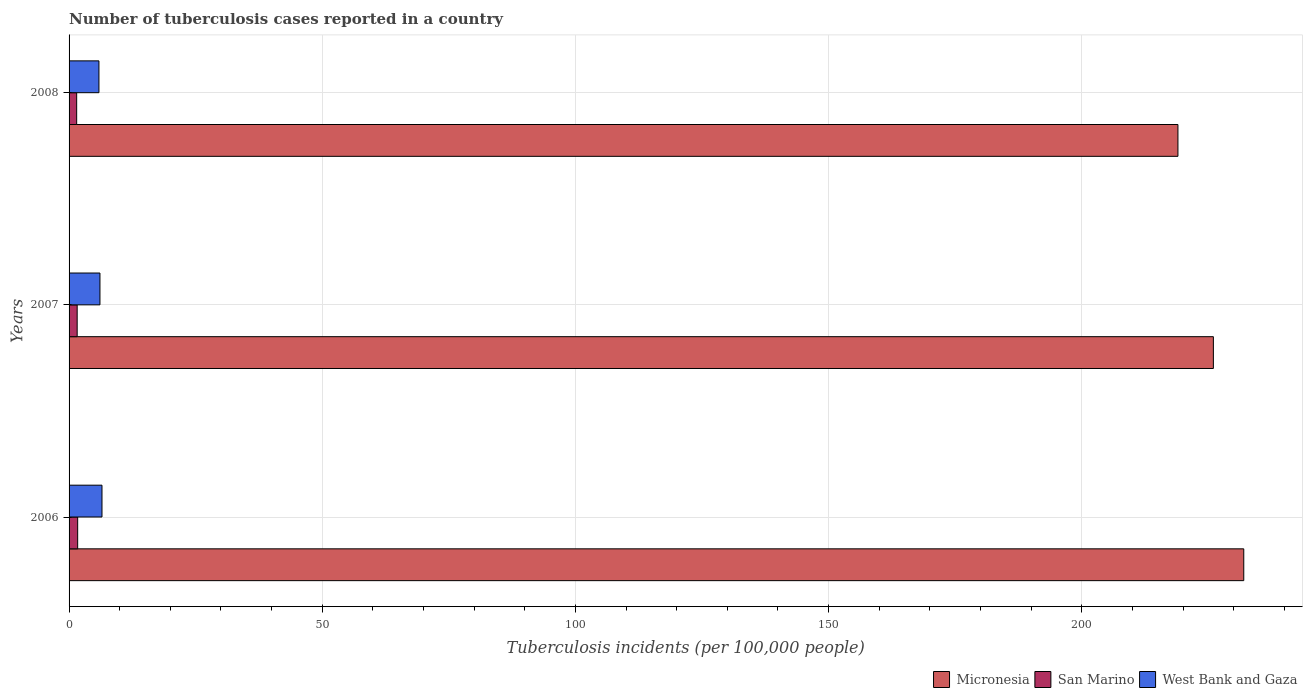Are the number of bars per tick equal to the number of legend labels?
Your response must be concise. Yes. In how many cases, is the number of bars for a given year not equal to the number of legend labels?
Offer a very short reply. 0. Across all years, what is the maximum number of tuberculosis cases reported in in Micronesia?
Keep it short and to the point. 232. In which year was the number of tuberculosis cases reported in in Micronesia maximum?
Give a very brief answer. 2006. What is the total number of tuberculosis cases reported in in San Marino in the graph?
Offer a terse response. 4.8. What is the difference between the number of tuberculosis cases reported in in Micronesia in 2006 and that in 2008?
Offer a terse response. 13. What is the difference between the number of tuberculosis cases reported in in San Marino in 2006 and the number of tuberculosis cases reported in in Micronesia in 2008?
Offer a terse response. -217.3. What is the average number of tuberculosis cases reported in in San Marino per year?
Provide a short and direct response. 1.6. In the year 2006, what is the difference between the number of tuberculosis cases reported in in West Bank and Gaza and number of tuberculosis cases reported in in Micronesia?
Keep it short and to the point. -225.5. What is the ratio of the number of tuberculosis cases reported in in Micronesia in 2007 to that in 2008?
Make the answer very short. 1.03. What is the difference between the highest and the second highest number of tuberculosis cases reported in in West Bank and Gaza?
Make the answer very short. 0.4. What is the difference between the highest and the lowest number of tuberculosis cases reported in in Micronesia?
Make the answer very short. 13. What does the 1st bar from the top in 2008 represents?
Provide a short and direct response. West Bank and Gaza. What does the 3rd bar from the bottom in 2008 represents?
Keep it short and to the point. West Bank and Gaza. Is it the case that in every year, the sum of the number of tuberculosis cases reported in in Micronesia and number of tuberculosis cases reported in in San Marino is greater than the number of tuberculosis cases reported in in West Bank and Gaza?
Keep it short and to the point. Yes. How many bars are there?
Ensure brevity in your answer.  9. Are all the bars in the graph horizontal?
Keep it short and to the point. Yes. How many years are there in the graph?
Ensure brevity in your answer.  3. Does the graph contain any zero values?
Ensure brevity in your answer.  No. Does the graph contain grids?
Keep it short and to the point. Yes. Where does the legend appear in the graph?
Give a very brief answer. Bottom right. How many legend labels are there?
Your answer should be very brief. 3. What is the title of the graph?
Your response must be concise. Number of tuberculosis cases reported in a country. Does "Maldives" appear as one of the legend labels in the graph?
Provide a short and direct response. No. What is the label or title of the X-axis?
Keep it short and to the point. Tuberculosis incidents (per 100,0 people). What is the label or title of the Y-axis?
Offer a terse response. Years. What is the Tuberculosis incidents (per 100,000 people) in Micronesia in 2006?
Ensure brevity in your answer.  232. What is the Tuberculosis incidents (per 100,000 people) of Micronesia in 2007?
Offer a terse response. 226. What is the Tuberculosis incidents (per 100,000 people) of West Bank and Gaza in 2007?
Offer a terse response. 6.1. What is the Tuberculosis incidents (per 100,000 people) of Micronesia in 2008?
Your response must be concise. 219. What is the Tuberculosis incidents (per 100,000 people) in San Marino in 2008?
Your response must be concise. 1.5. What is the Tuberculosis incidents (per 100,000 people) of West Bank and Gaza in 2008?
Keep it short and to the point. 5.9. Across all years, what is the maximum Tuberculosis incidents (per 100,000 people) of Micronesia?
Provide a succinct answer. 232. Across all years, what is the maximum Tuberculosis incidents (per 100,000 people) of San Marino?
Keep it short and to the point. 1.7. Across all years, what is the maximum Tuberculosis incidents (per 100,000 people) in West Bank and Gaza?
Offer a very short reply. 6.5. Across all years, what is the minimum Tuberculosis incidents (per 100,000 people) of Micronesia?
Give a very brief answer. 219. What is the total Tuberculosis incidents (per 100,000 people) in Micronesia in the graph?
Your response must be concise. 677. What is the difference between the Tuberculosis incidents (per 100,000 people) in West Bank and Gaza in 2006 and that in 2007?
Ensure brevity in your answer.  0.4. What is the difference between the Tuberculosis incidents (per 100,000 people) of West Bank and Gaza in 2006 and that in 2008?
Provide a succinct answer. 0.6. What is the difference between the Tuberculosis incidents (per 100,000 people) in San Marino in 2007 and that in 2008?
Keep it short and to the point. 0.1. What is the difference between the Tuberculosis incidents (per 100,000 people) in Micronesia in 2006 and the Tuberculosis incidents (per 100,000 people) in San Marino in 2007?
Keep it short and to the point. 230.4. What is the difference between the Tuberculosis incidents (per 100,000 people) of Micronesia in 2006 and the Tuberculosis incidents (per 100,000 people) of West Bank and Gaza in 2007?
Give a very brief answer. 225.9. What is the difference between the Tuberculosis incidents (per 100,000 people) of Micronesia in 2006 and the Tuberculosis incidents (per 100,000 people) of San Marino in 2008?
Your answer should be compact. 230.5. What is the difference between the Tuberculosis incidents (per 100,000 people) in Micronesia in 2006 and the Tuberculosis incidents (per 100,000 people) in West Bank and Gaza in 2008?
Keep it short and to the point. 226.1. What is the difference between the Tuberculosis incidents (per 100,000 people) in San Marino in 2006 and the Tuberculosis incidents (per 100,000 people) in West Bank and Gaza in 2008?
Ensure brevity in your answer.  -4.2. What is the difference between the Tuberculosis incidents (per 100,000 people) of Micronesia in 2007 and the Tuberculosis incidents (per 100,000 people) of San Marino in 2008?
Ensure brevity in your answer.  224.5. What is the difference between the Tuberculosis incidents (per 100,000 people) in Micronesia in 2007 and the Tuberculosis incidents (per 100,000 people) in West Bank and Gaza in 2008?
Give a very brief answer. 220.1. What is the average Tuberculosis incidents (per 100,000 people) in Micronesia per year?
Provide a succinct answer. 225.67. What is the average Tuberculosis incidents (per 100,000 people) in San Marino per year?
Offer a very short reply. 1.6. What is the average Tuberculosis incidents (per 100,000 people) in West Bank and Gaza per year?
Make the answer very short. 6.17. In the year 2006, what is the difference between the Tuberculosis incidents (per 100,000 people) of Micronesia and Tuberculosis incidents (per 100,000 people) of San Marino?
Provide a succinct answer. 230.3. In the year 2006, what is the difference between the Tuberculosis incidents (per 100,000 people) of Micronesia and Tuberculosis incidents (per 100,000 people) of West Bank and Gaza?
Offer a very short reply. 225.5. In the year 2007, what is the difference between the Tuberculosis incidents (per 100,000 people) of Micronesia and Tuberculosis incidents (per 100,000 people) of San Marino?
Provide a short and direct response. 224.4. In the year 2007, what is the difference between the Tuberculosis incidents (per 100,000 people) in Micronesia and Tuberculosis incidents (per 100,000 people) in West Bank and Gaza?
Provide a short and direct response. 219.9. In the year 2008, what is the difference between the Tuberculosis incidents (per 100,000 people) in Micronesia and Tuberculosis incidents (per 100,000 people) in San Marino?
Your answer should be compact. 217.5. In the year 2008, what is the difference between the Tuberculosis incidents (per 100,000 people) of Micronesia and Tuberculosis incidents (per 100,000 people) of West Bank and Gaza?
Ensure brevity in your answer.  213.1. What is the ratio of the Tuberculosis incidents (per 100,000 people) in Micronesia in 2006 to that in 2007?
Keep it short and to the point. 1.03. What is the ratio of the Tuberculosis incidents (per 100,000 people) in San Marino in 2006 to that in 2007?
Your answer should be very brief. 1.06. What is the ratio of the Tuberculosis incidents (per 100,000 people) of West Bank and Gaza in 2006 to that in 2007?
Ensure brevity in your answer.  1.07. What is the ratio of the Tuberculosis incidents (per 100,000 people) of Micronesia in 2006 to that in 2008?
Your answer should be very brief. 1.06. What is the ratio of the Tuberculosis incidents (per 100,000 people) of San Marino in 2006 to that in 2008?
Ensure brevity in your answer.  1.13. What is the ratio of the Tuberculosis incidents (per 100,000 people) in West Bank and Gaza in 2006 to that in 2008?
Give a very brief answer. 1.1. What is the ratio of the Tuberculosis incidents (per 100,000 people) of Micronesia in 2007 to that in 2008?
Provide a short and direct response. 1.03. What is the ratio of the Tuberculosis incidents (per 100,000 people) of San Marino in 2007 to that in 2008?
Offer a very short reply. 1.07. What is the ratio of the Tuberculosis incidents (per 100,000 people) in West Bank and Gaza in 2007 to that in 2008?
Make the answer very short. 1.03. What is the difference between the highest and the second highest Tuberculosis incidents (per 100,000 people) in Micronesia?
Give a very brief answer. 6. What is the difference between the highest and the second highest Tuberculosis incidents (per 100,000 people) of West Bank and Gaza?
Provide a succinct answer. 0.4. What is the difference between the highest and the lowest Tuberculosis incidents (per 100,000 people) in San Marino?
Keep it short and to the point. 0.2. 